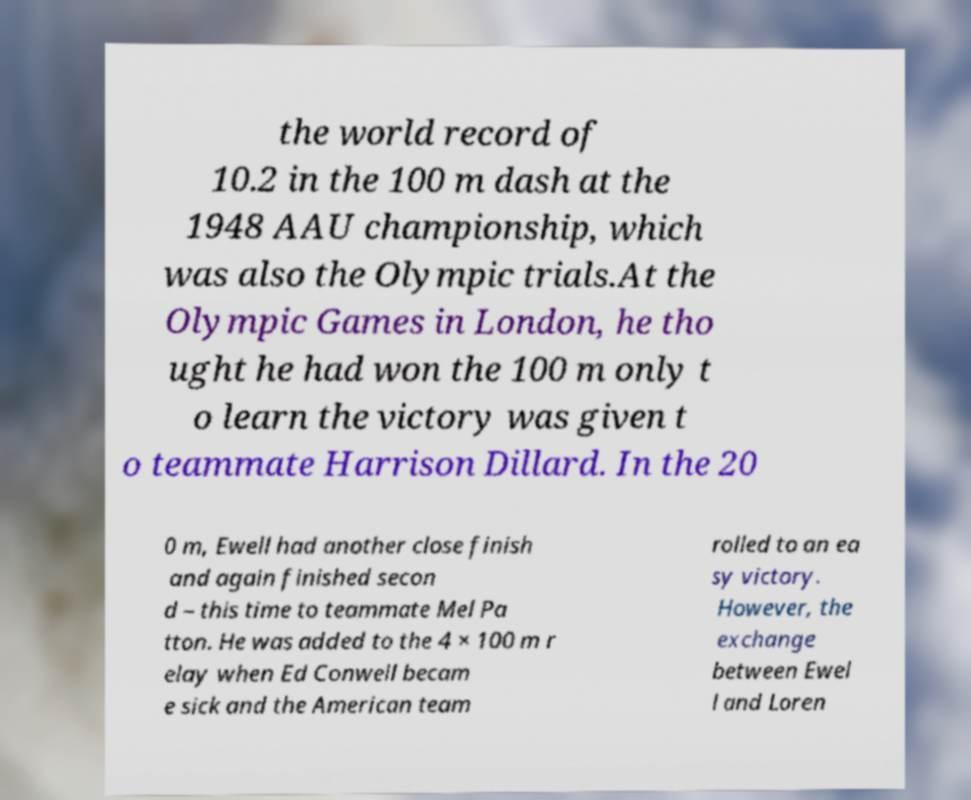Please identify and transcribe the text found in this image. the world record of 10.2 in the 100 m dash at the 1948 AAU championship, which was also the Olympic trials.At the Olympic Games in London, he tho ught he had won the 100 m only t o learn the victory was given t o teammate Harrison Dillard. In the 20 0 m, Ewell had another close finish and again finished secon d – this time to teammate Mel Pa tton. He was added to the 4 × 100 m r elay when Ed Conwell becam e sick and the American team rolled to an ea sy victory. However, the exchange between Ewel l and Loren 